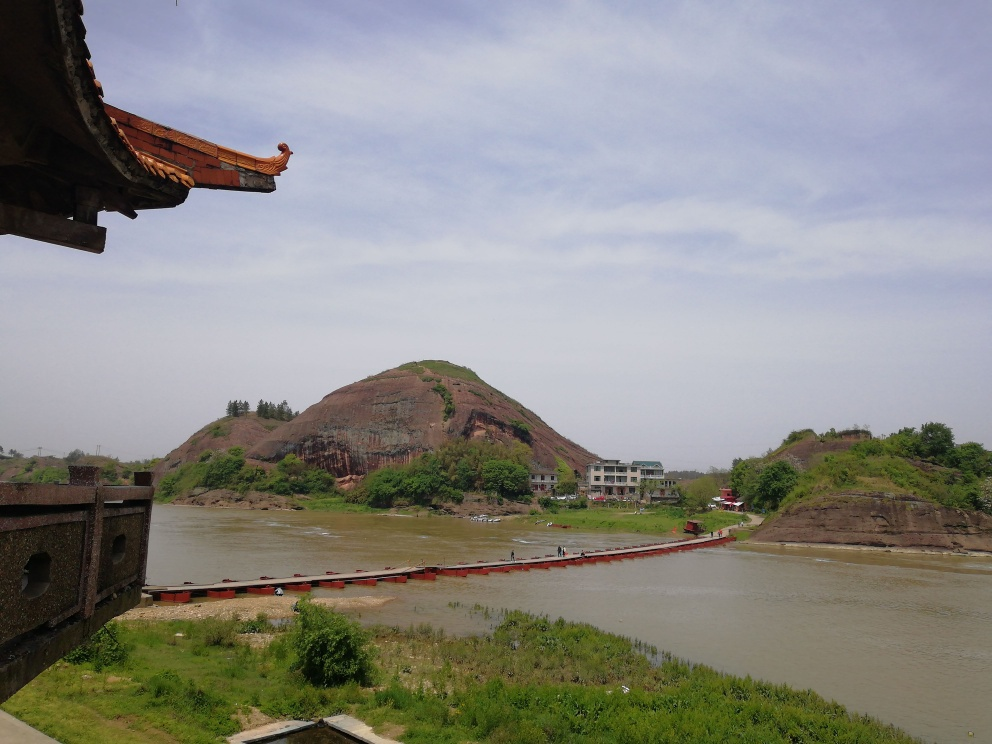Can you describe the historical significance of this location? The image shows a landscape dominated by a hill with what appears to be a rocky outcrop. Although I cannot provide specific historical details without knowing the exact location, hills and natural formations like this are often sites of historical importance in many cultures. They can be associated with ancient fortifications, religious practices, or significant events in local history. 